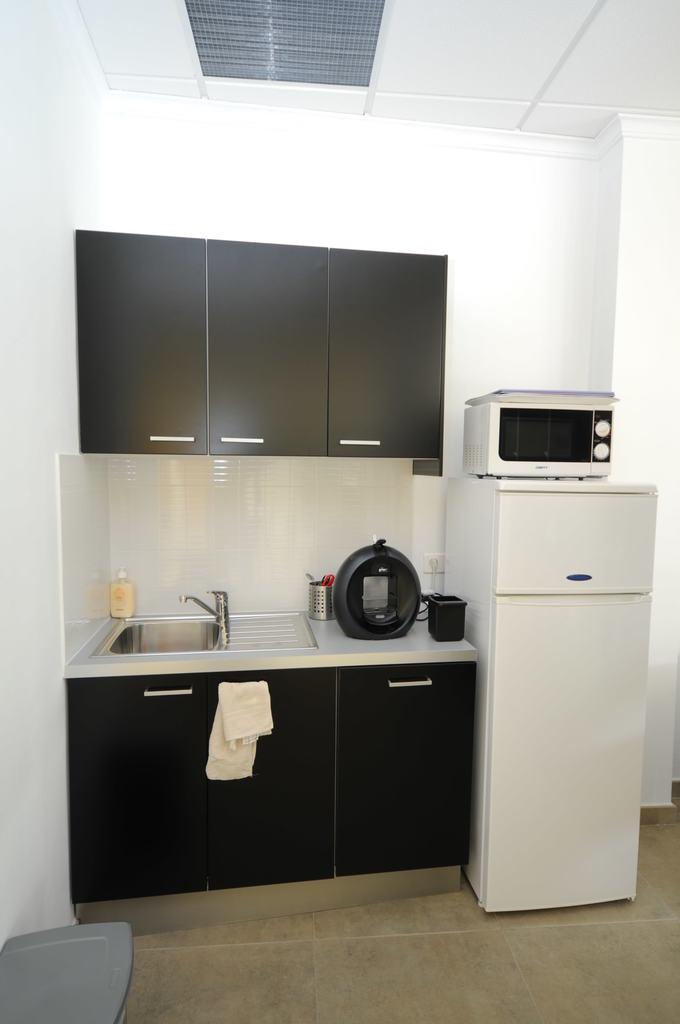What can be found in the image for washing hands? There is a wash basin and water taps in the image for washing hands. What is available for cleaning hands after washing? There is a hand wash in the image for cleaning hands after washing. Where can items be stored in the image? There are cupboards in the image for storing items. What is provided for drying hands in the image? There is a napkin in the image for drying hands. What appliance is present for keeping food cold in the image? There is a refrigerator in the image for keeping food cold. What appliance is present for cooking in the image? There is an oven in the image for cooking. What is the structure above the image? There is a roof in the image. What is the structure surrounding the image? There is a wall in the image. What can be found in the image for cutting purposes? There is a container with scissors in the image for cutting purposes. What is the surface on which the objects are placed in the image? There is a floor in the image. What type of trousers are hanging on the wall in the image? There are no trousers present in the image. What kind of stone is used to build the wall in the image? The image does not provide information about the type of stone used to build the wall, and there is no mention of stone in the image. What kind of marble is used for the floor in the image? The image does not provide information about the type of material used for the floor, and there is no mention of marble in the image. 